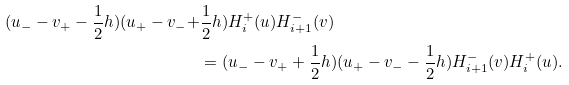<formula> <loc_0><loc_0><loc_500><loc_500>( u _ { - } - v _ { + } - \frac { 1 } { 2 } h ) ( u _ { + } - v _ { - } + & \frac { 1 } { 2 } h ) H _ { i } ^ { + } ( u ) H _ { i + 1 } ^ { - } ( v ) \\ & = ( u _ { - } - v _ { + } + \frac { 1 } { 2 } h ) ( u _ { + } - v _ { - } - \frac { 1 } { 2 } h ) H _ { i + 1 } ^ { - } ( v ) H _ { i } ^ { + } ( u ) .</formula> 